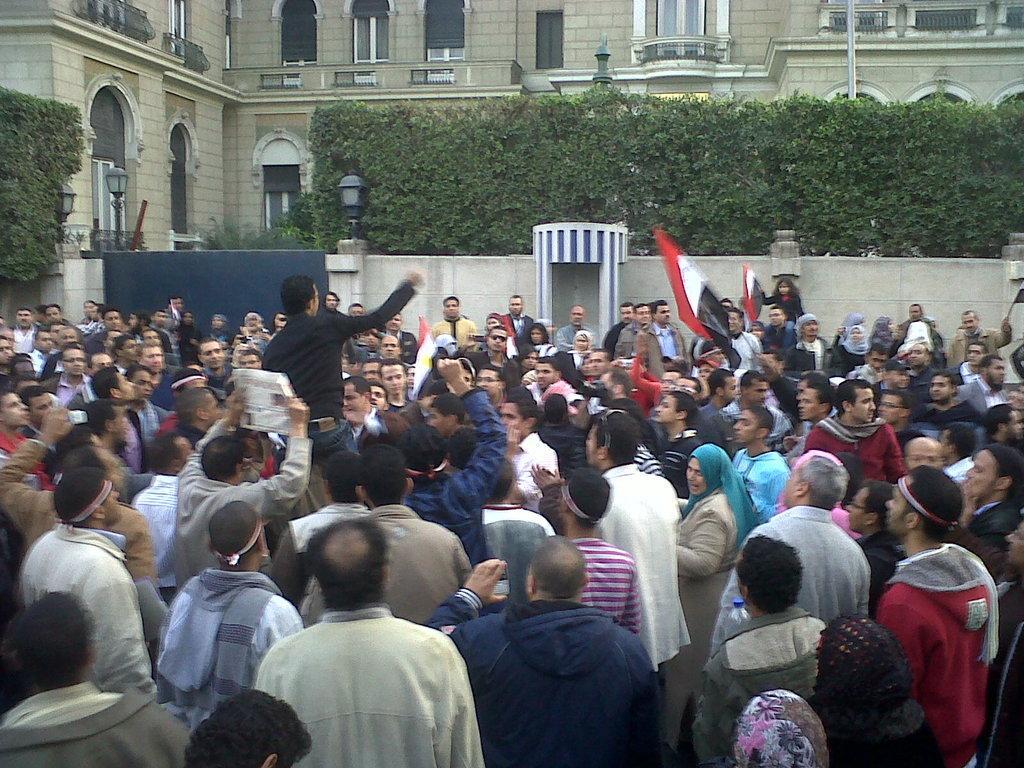Describe this image in one or two sentences. In this picture, we see people are standing on the road. The man in black jacket is holding a flag which is in white, red and black color. The girl in black jacket is also holding a same color flag. The man in grey T-shirt is holding a newspaper in his hand. In front of him, we see a man in black T-shirt is standing. Behind them, we see a wall and gate. There are street lights, shrubs and buildings in the background. 